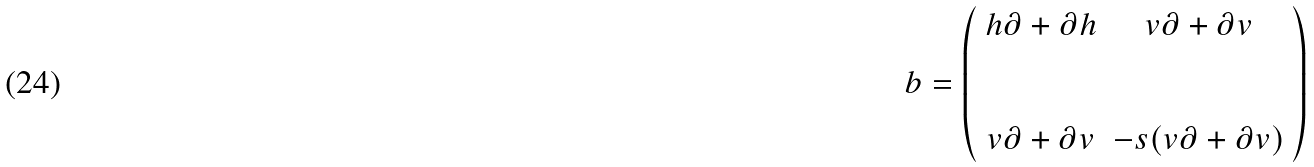Convert formula to latex. <formula><loc_0><loc_0><loc_500><loc_500>b = \left ( \begin{array} { c c } h \partial + \partial h & v \partial + \partial v \\ \\ \\ v \partial + \partial v & - s ( v \partial + \partial v ) \end{array} \right )</formula> 